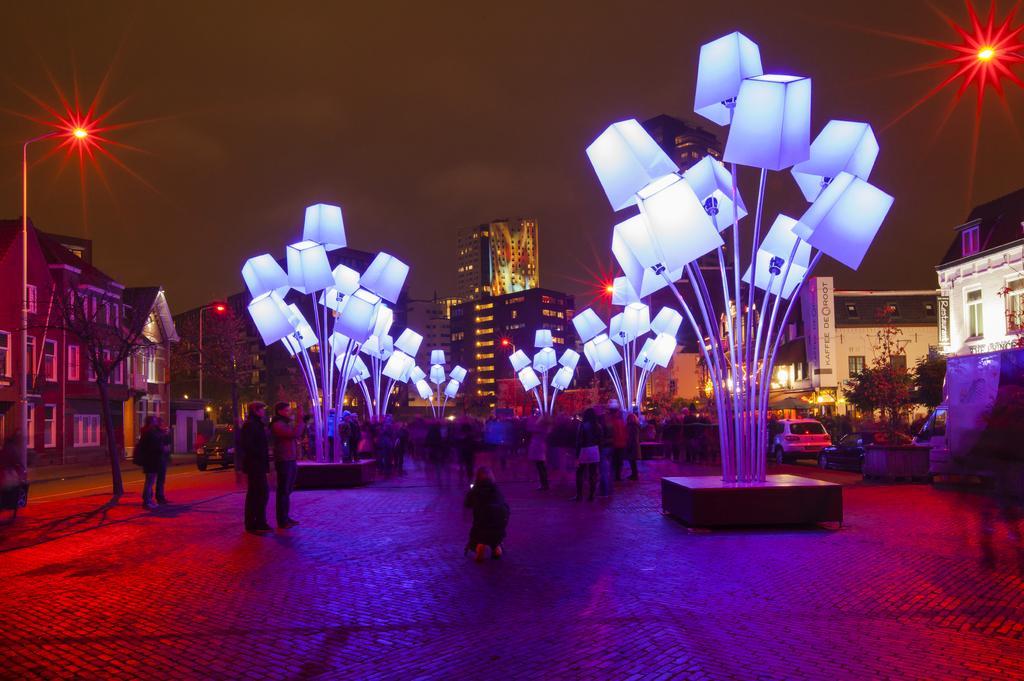In one or two sentences, can you explain what this image depicts? In this image we can see many buildings. There are few trees in the image. There are few vehicles in the image. There are many people in the image. There are few lamps in the image. There are few street lights in the image. There is some text on the advertising banner at the right side of the image. 